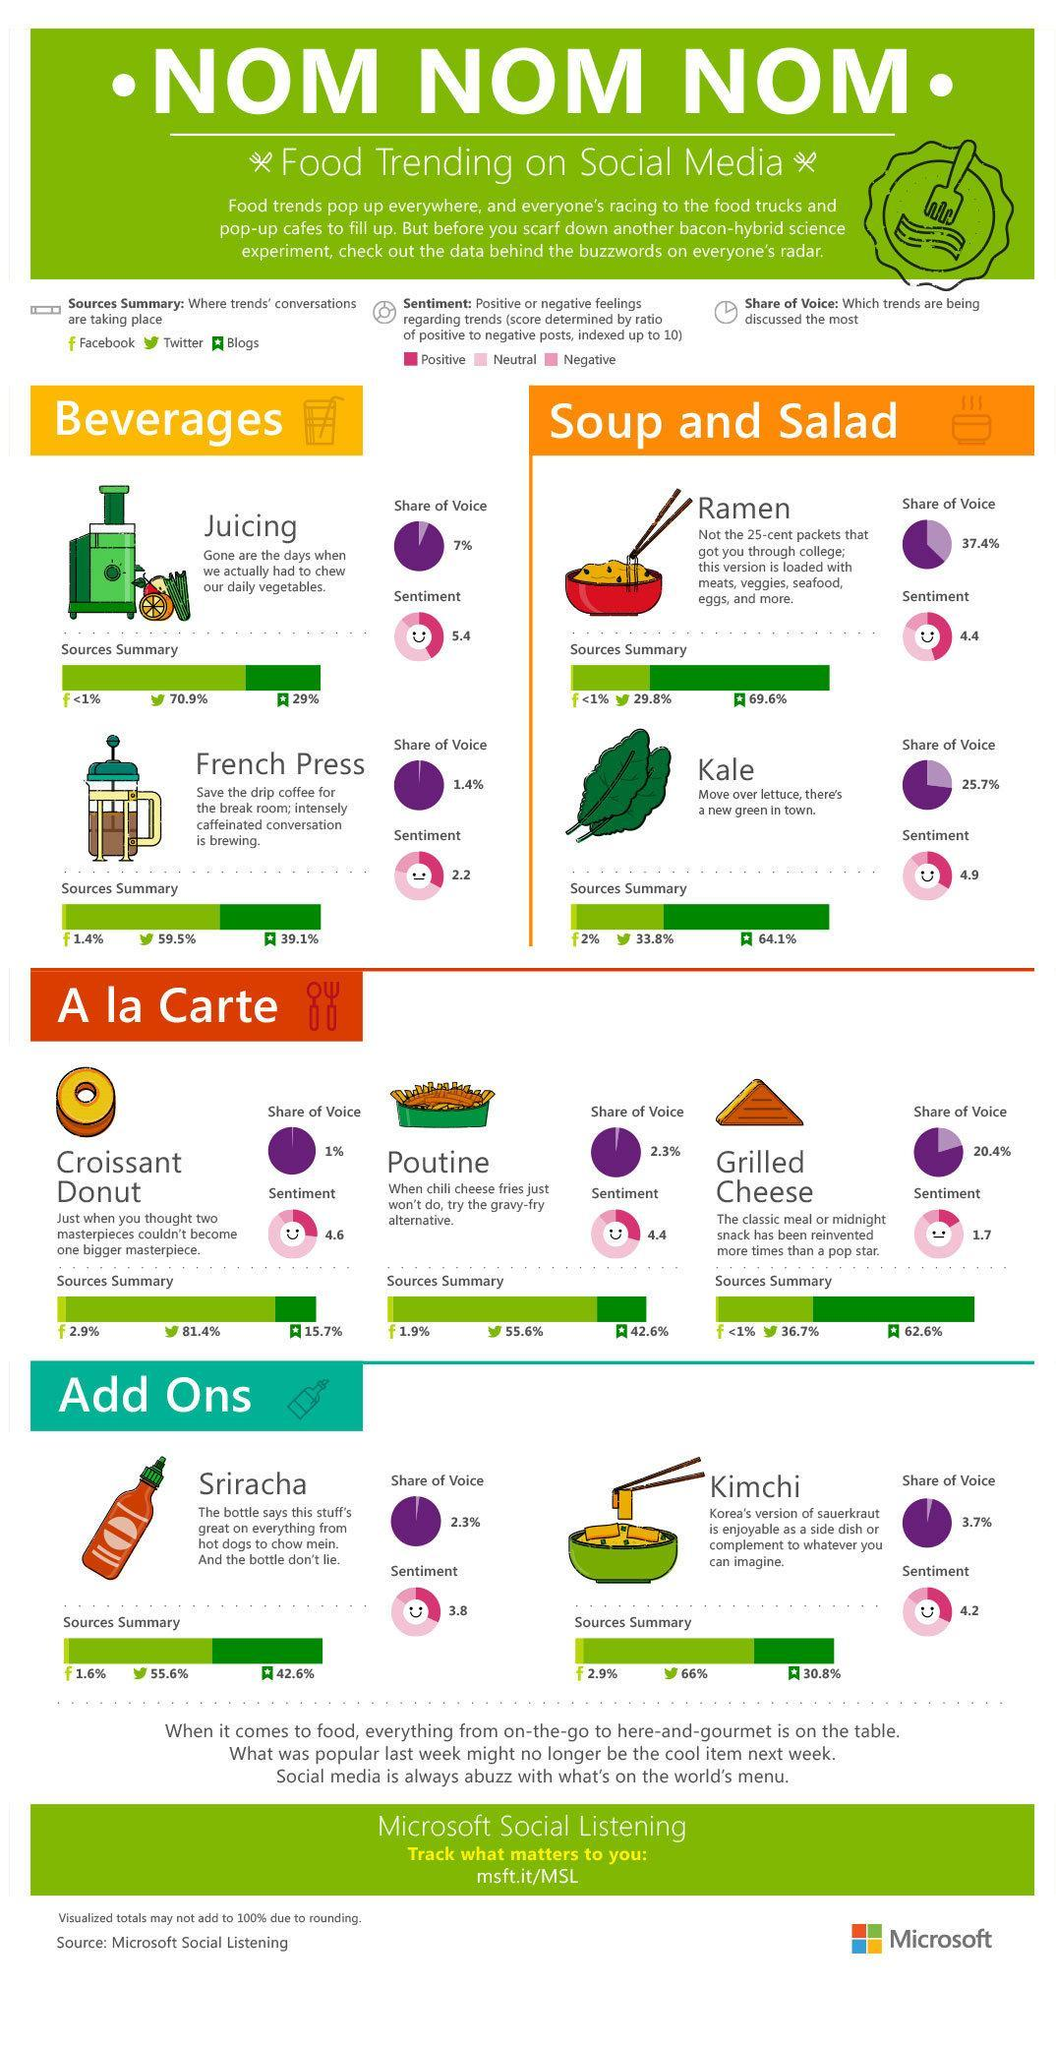Which are the two beverage trends?
Answer the question with a short phrase. Juicing, French press Which trend has the lowest sentiment index? Grilled cheese On which social media platform is Poutine mostly discussed? Twitter Which is the new green that is preferred over lettuce? Kale Where do conversations on kimchi mostly take place? Twitter Which food trend has the highest sentiment index? Juicing What are the trending foods under A la Carte? Croissant Donut, Poutine, grilled cheese Which sauce tastes great on hot dogs and chow mein? Sriracha What is the share of voice for Kimchi? 3.7% What is the share of voice for Kale? 25.7% Which are the two foods trending under 'soup and salad'? Ramen, Kale What percentage of conversations on grilled cheese take place on Twitter? 36.7% Which is the most trending food on Twitter? Croissant Donut What percentage of conversation on Sriracha take place on blogs? 42.6% Which food has the highest "share of voice" ? Ramen What is the sentiment index for French press? 2.2 Which are the 2 trending 'add ons'? Sriracha, kimchi How many  trending foods are shown under A la Carte? 3 Which is the trending Korean side dish? Kimchi Which has a higher sentiment index, Croissant Donut or Poutine? Croissant Donut What is the share of voice for Poutine? 2.3% Which trend has the second highest sentiment index? Kale 